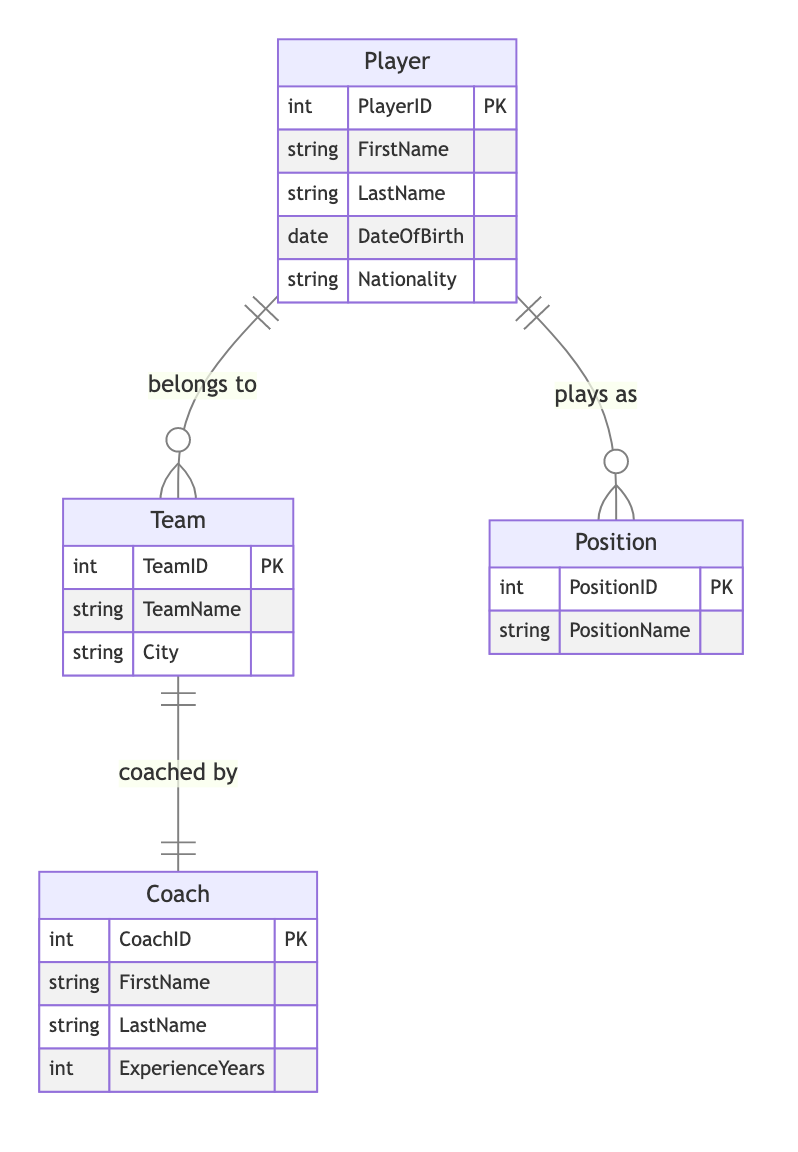What are the entities in the diagram? The diagram contains four entities: Player, Team, Position, and Coach.
Answer: Player, Team, Position, Coach How many attributes does the Player entity have? The Player entity has five attributes: PlayerID, FirstName, LastName, DateOfBirth, and Nationality.
Answer: 5 What is the relationship type between Player and Team? The relationship type between Player and Team is 'ManyToOne', indicating that many players can belong to one team.
Answer: ManyToOne How many direct relationships does the Team entity have? The Team entity has two direct relationships: one with Player and one with Coach.
Answer: 2 Who is coaching the Team? The Team is coached by a Coach entity, which has a one-to-one relationship with Team.
Answer: Coach What attribute of the Coach entity signifies their experience? The Coach entity has an attribute called ExperienceYears, which indicates the number of years of coaching experience.
Answer: ExperienceYears What type of relationship exists between Player and Position? The relationship between Player and Position is 'ManyToOne', meaning many players can play in one position.
Answer: ManyToOne How many positions can a Player hold? A Player can hold one Position, as indicated by the 'ManyToOne' relationship.
Answer: One What is the primary key of the Team entity? The primary key of the Team entity is TeamID.
Answer: TeamID Which entity has the attribute LastName? Both Player and Coach entities have the attribute LastName.
Answer: Player, Coach 